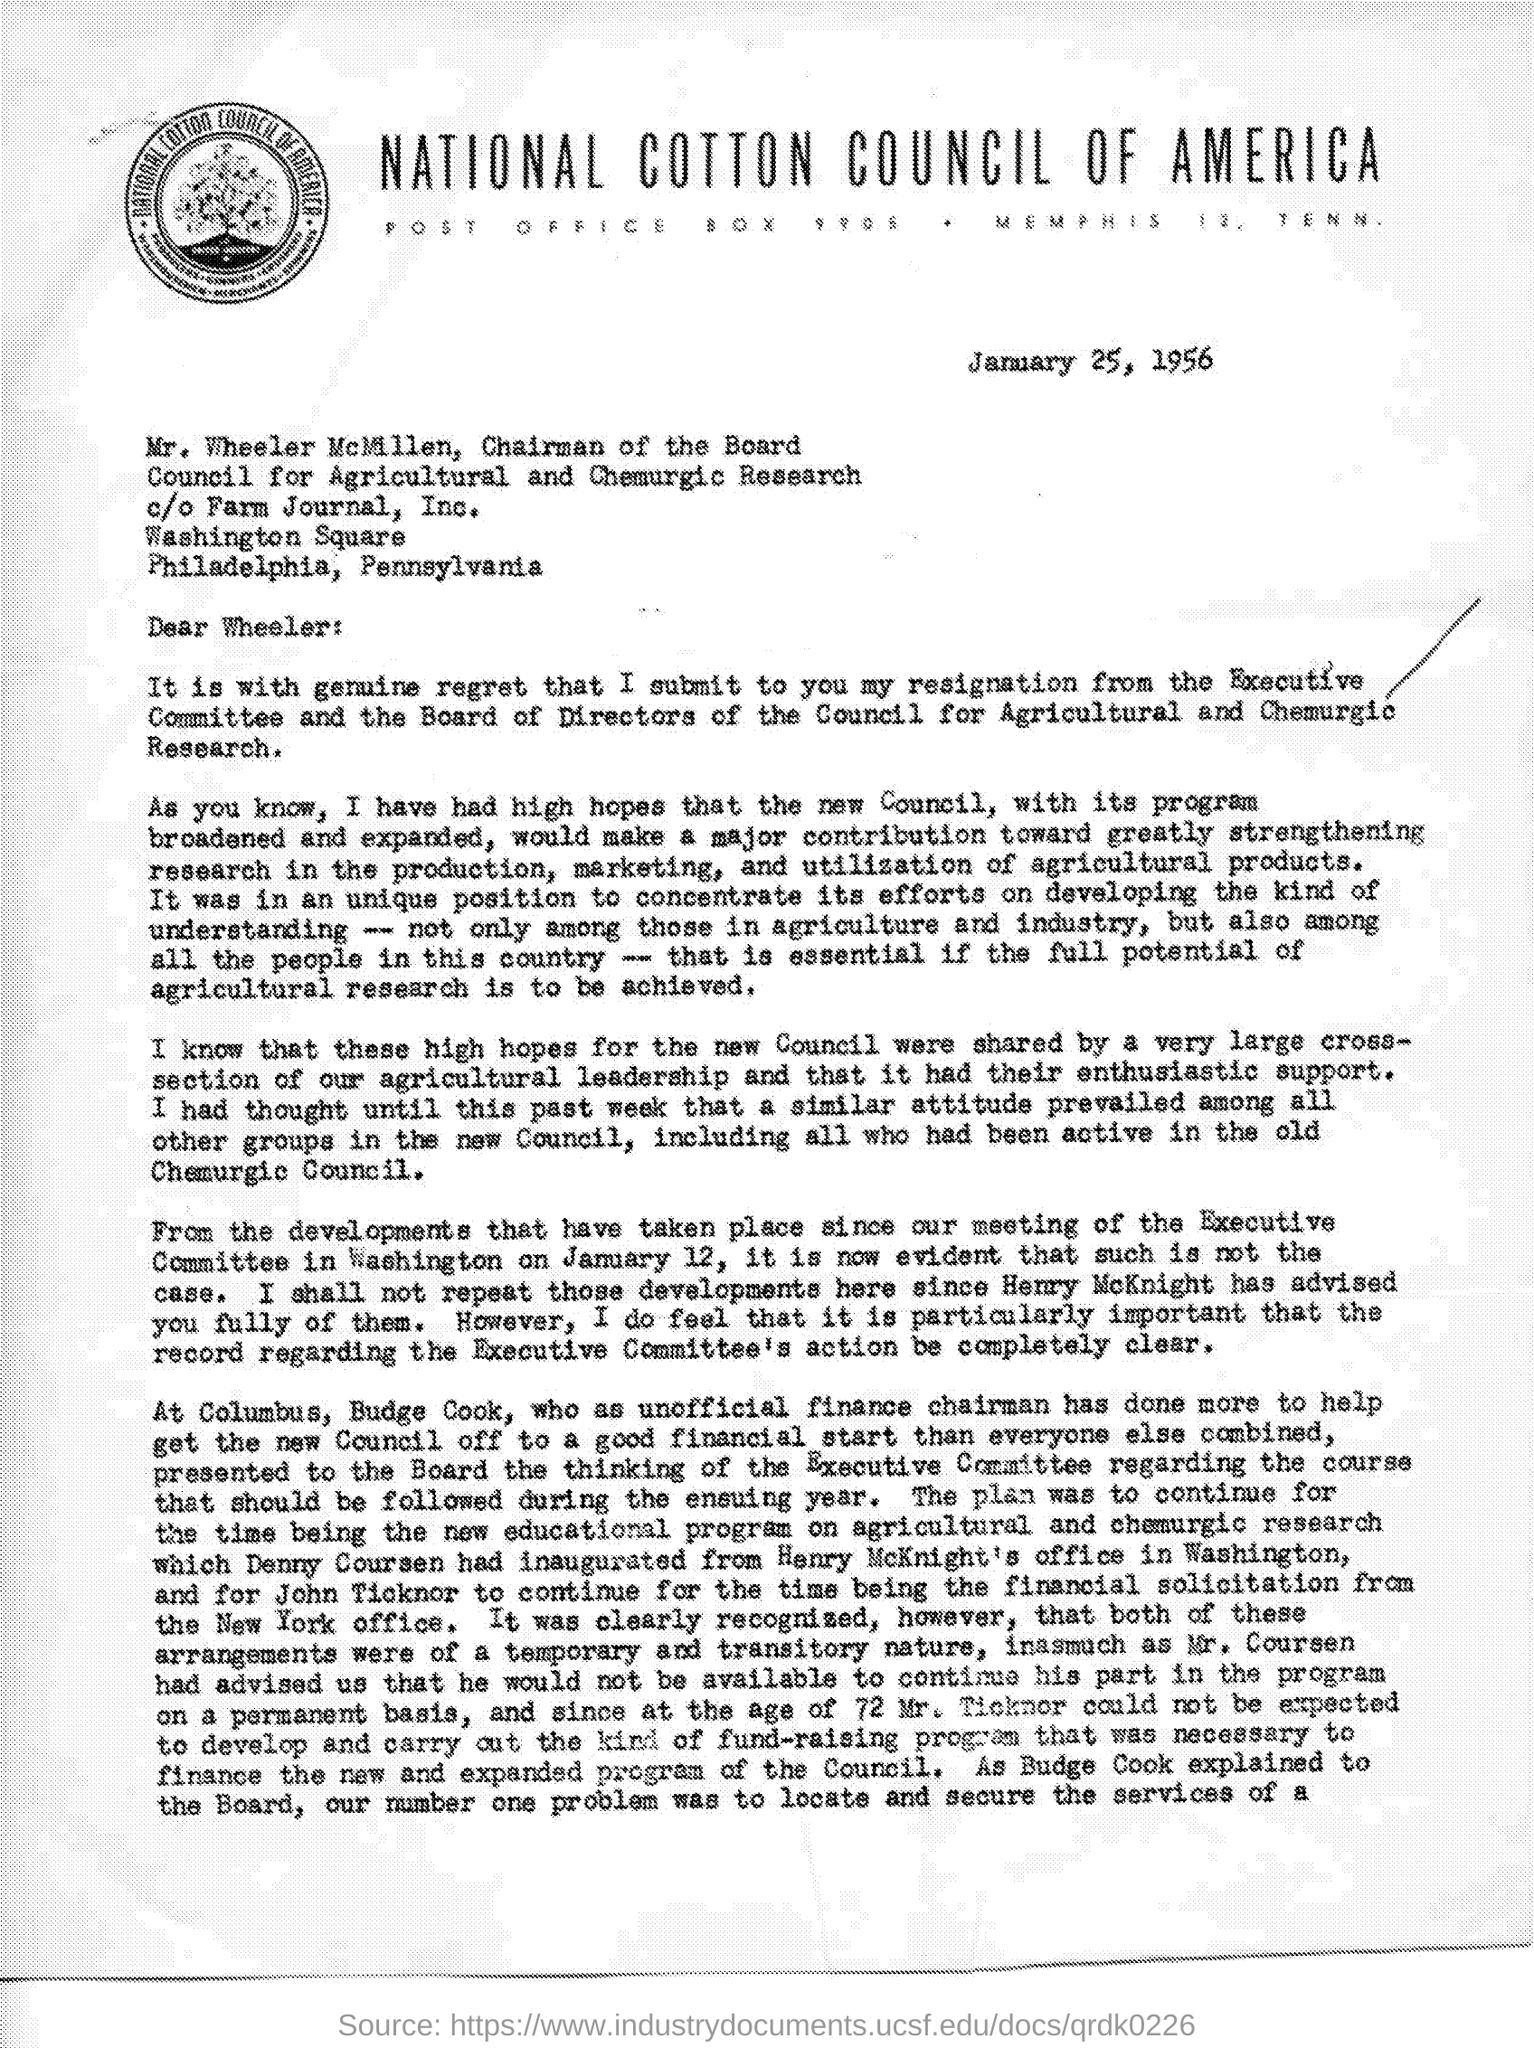Give some essential details in this illustration. The National Cotton Council of America is mentioned at the top of the page. The letter is dated January 25, 1956. The letter is addressed to Wheeler. 